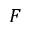Convert formula to latex. <formula><loc_0><loc_0><loc_500><loc_500>F</formula> 